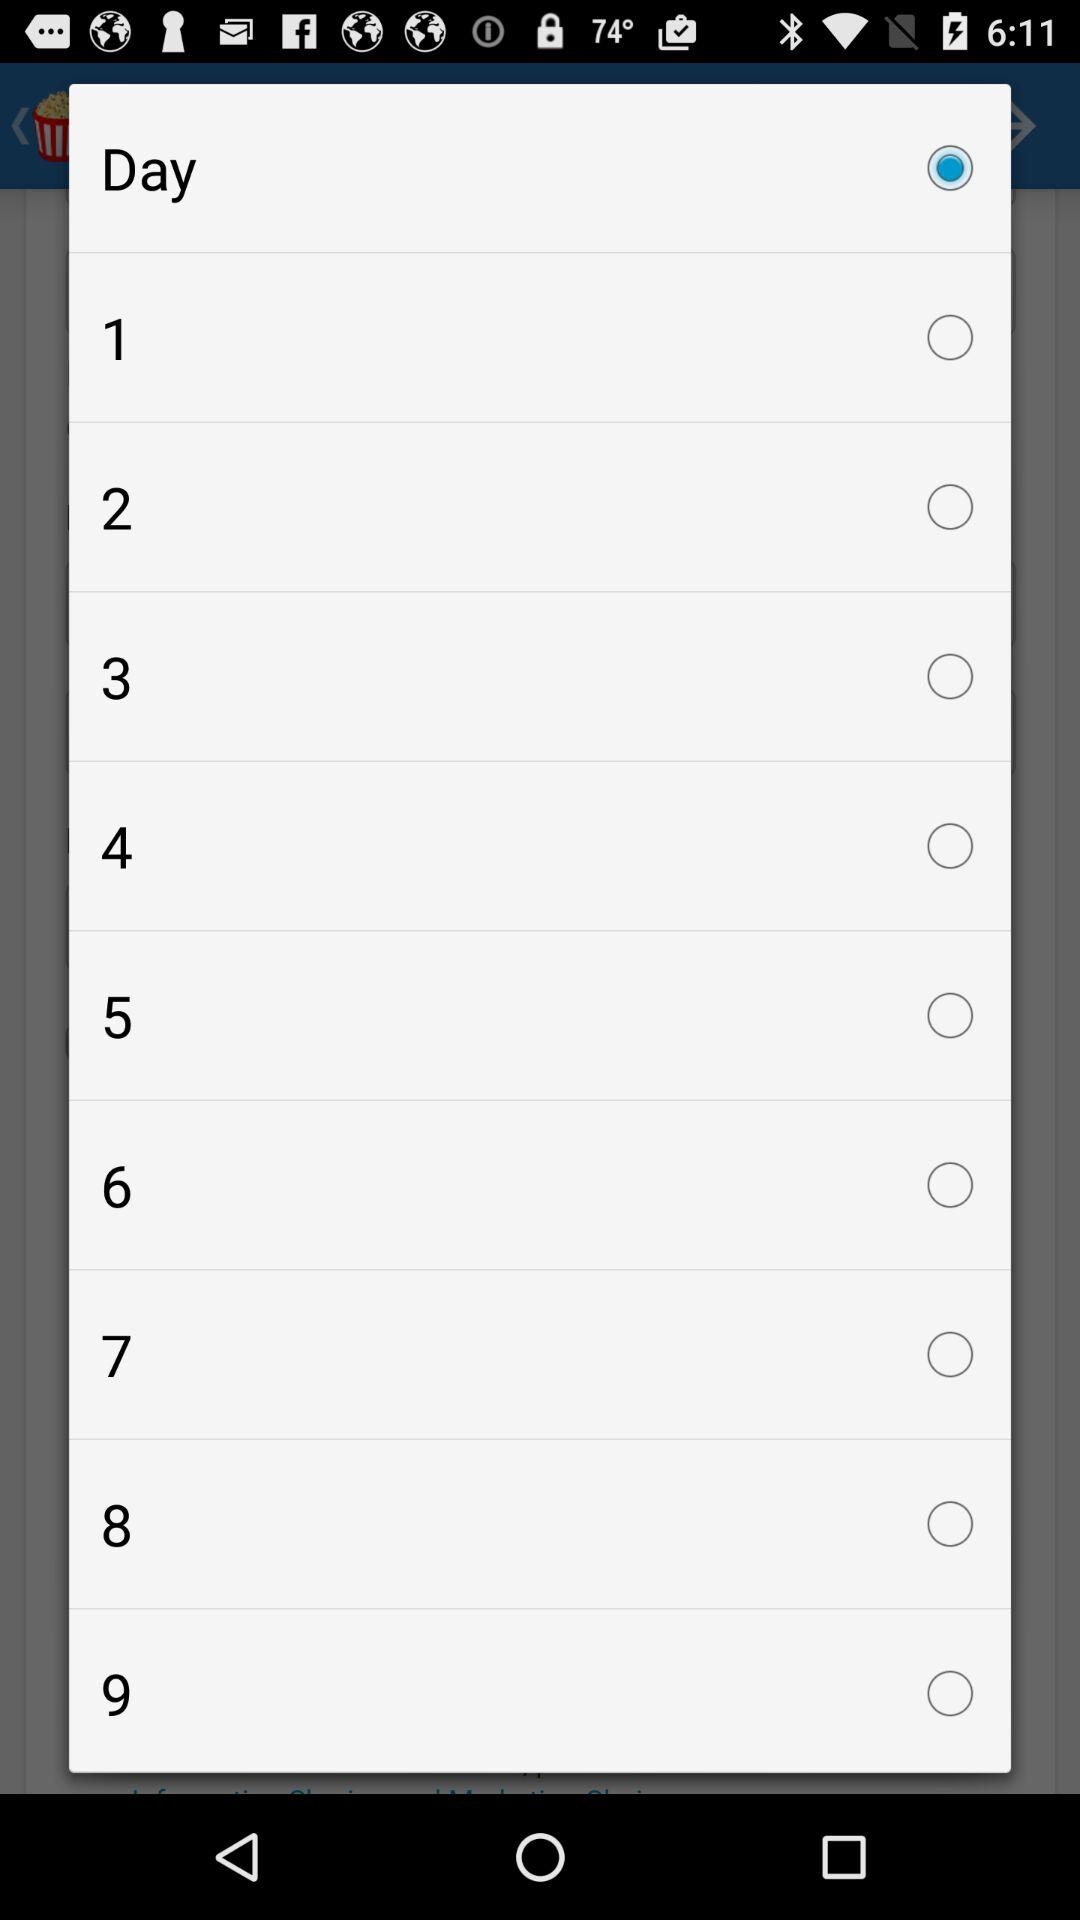What is the status of 3? The status is off. 